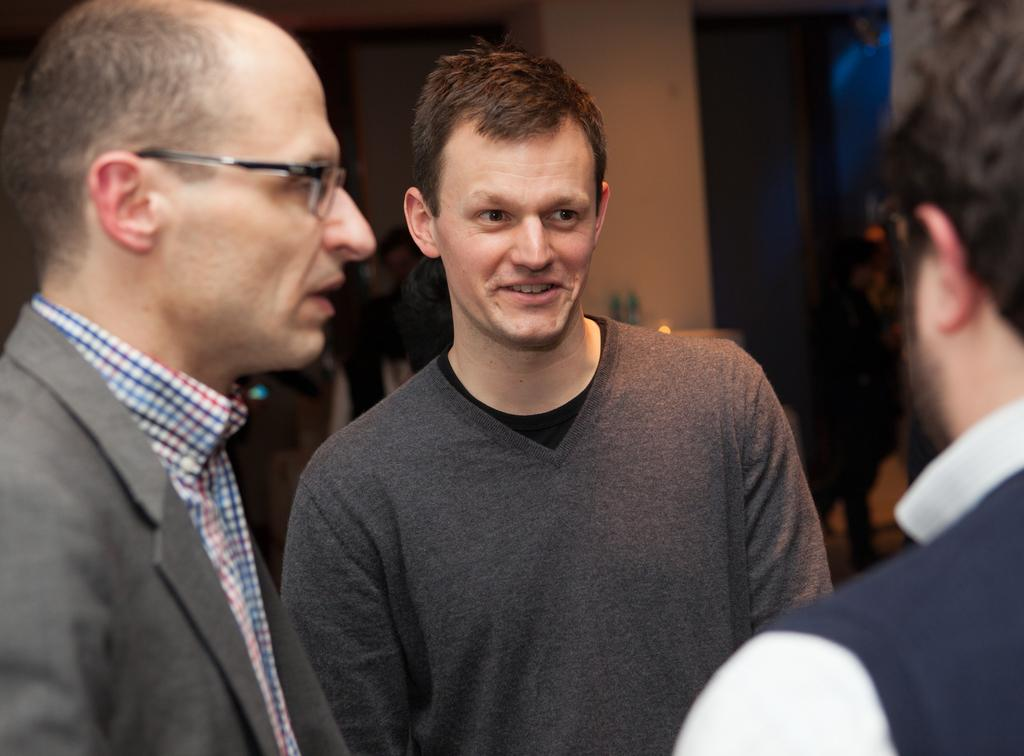How many people are in the image? There are three men in the image. What are the men wearing in the image? All three men are wearing blazers. What type of thing can be seen pulsating in the veins of the men in the image? There is no indication of pulsating things or veins in the image; it only shows three men wearing blazers. 